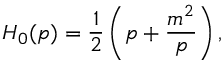<formula> <loc_0><loc_0><loc_500><loc_500>H _ { 0 } ( p ) = \frac { 1 } { 2 } \left ( p + \frac { m ^ { 2 } } { p } \right ) ,</formula> 